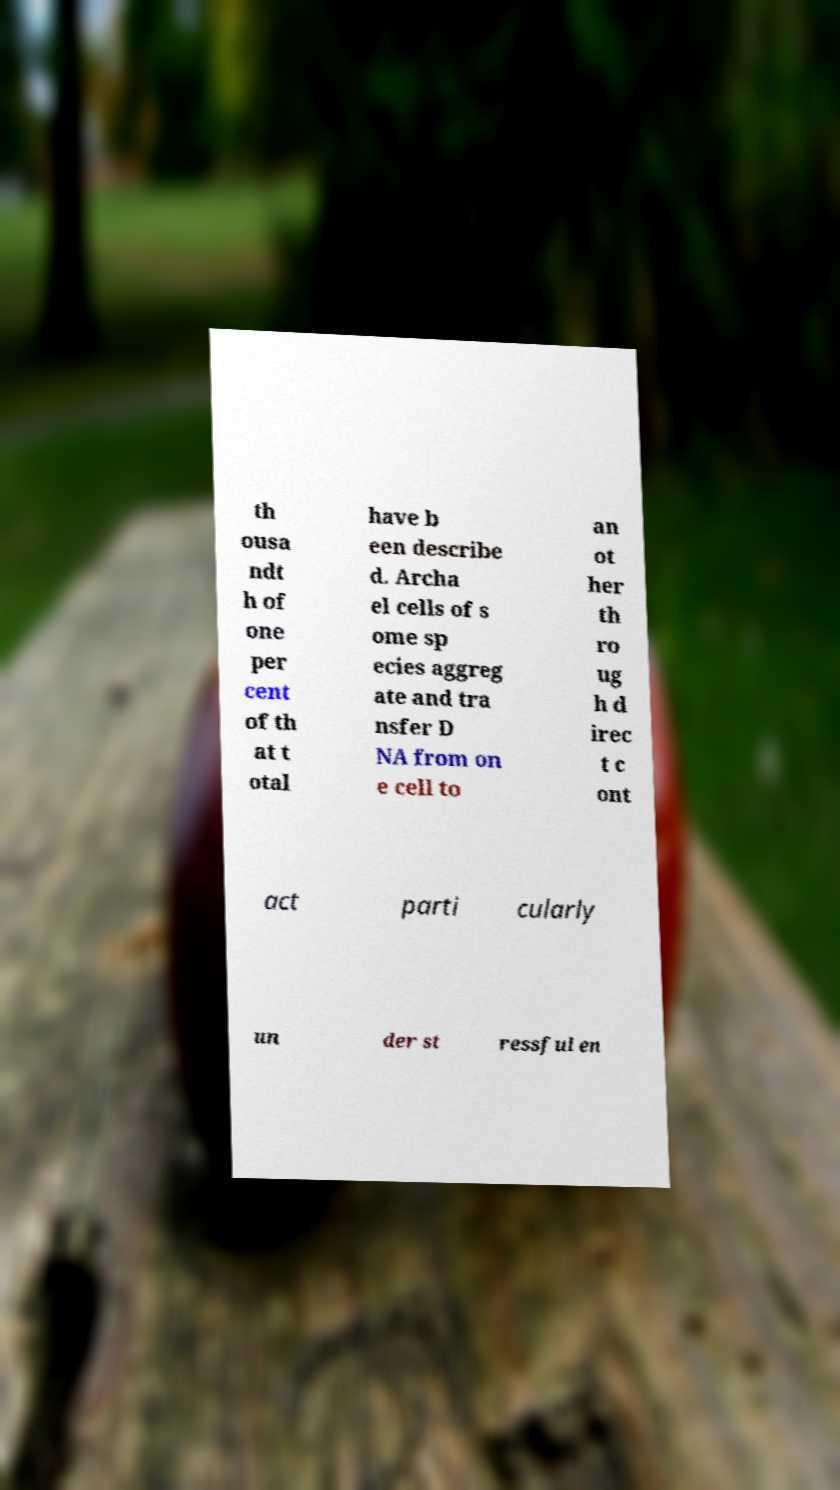Could you extract and type out the text from this image? th ousa ndt h of one per cent of th at t otal have b een describe d. Archa el cells of s ome sp ecies aggreg ate and tra nsfer D NA from on e cell to an ot her th ro ug h d irec t c ont act parti cularly un der st ressful en 